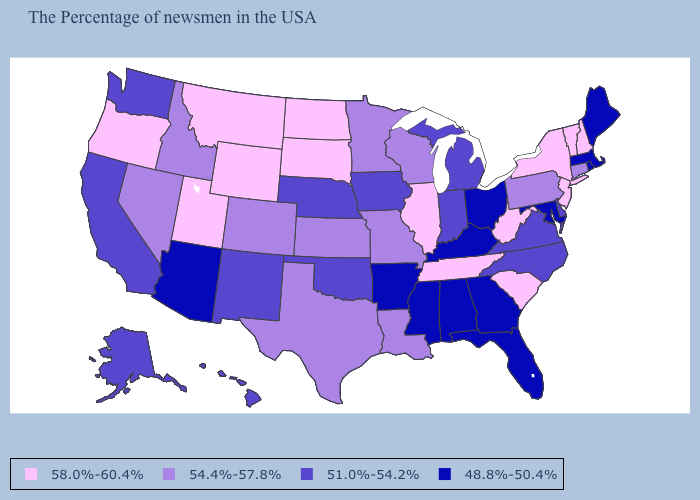Does Kansas have a lower value than West Virginia?
Short answer required. Yes. Does New Hampshire have the highest value in the USA?
Short answer required. Yes. What is the highest value in the USA?
Write a very short answer. 58.0%-60.4%. Among the states that border West Virginia , which have the highest value?
Answer briefly. Pennsylvania. What is the highest value in states that border Idaho?
Concise answer only. 58.0%-60.4%. What is the highest value in the USA?
Quick response, please. 58.0%-60.4%. Which states have the highest value in the USA?
Write a very short answer. New Hampshire, Vermont, New York, New Jersey, South Carolina, West Virginia, Tennessee, Illinois, South Dakota, North Dakota, Wyoming, Utah, Montana, Oregon. Among the states that border Massachusetts , which have the lowest value?
Write a very short answer. Rhode Island. Name the states that have a value in the range 58.0%-60.4%?
Short answer required. New Hampshire, Vermont, New York, New Jersey, South Carolina, West Virginia, Tennessee, Illinois, South Dakota, North Dakota, Wyoming, Utah, Montana, Oregon. Among the states that border Rhode Island , which have the highest value?
Short answer required. Connecticut. Is the legend a continuous bar?
Keep it brief. No. What is the lowest value in states that border Idaho?
Write a very short answer. 51.0%-54.2%. What is the value of Texas?
Short answer required. 54.4%-57.8%. Among the states that border Nevada , does Utah have the lowest value?
Give a very brief answer. No. Does South Dakota have the highest value in the MidWest?
Write a very short answer. Yes. 